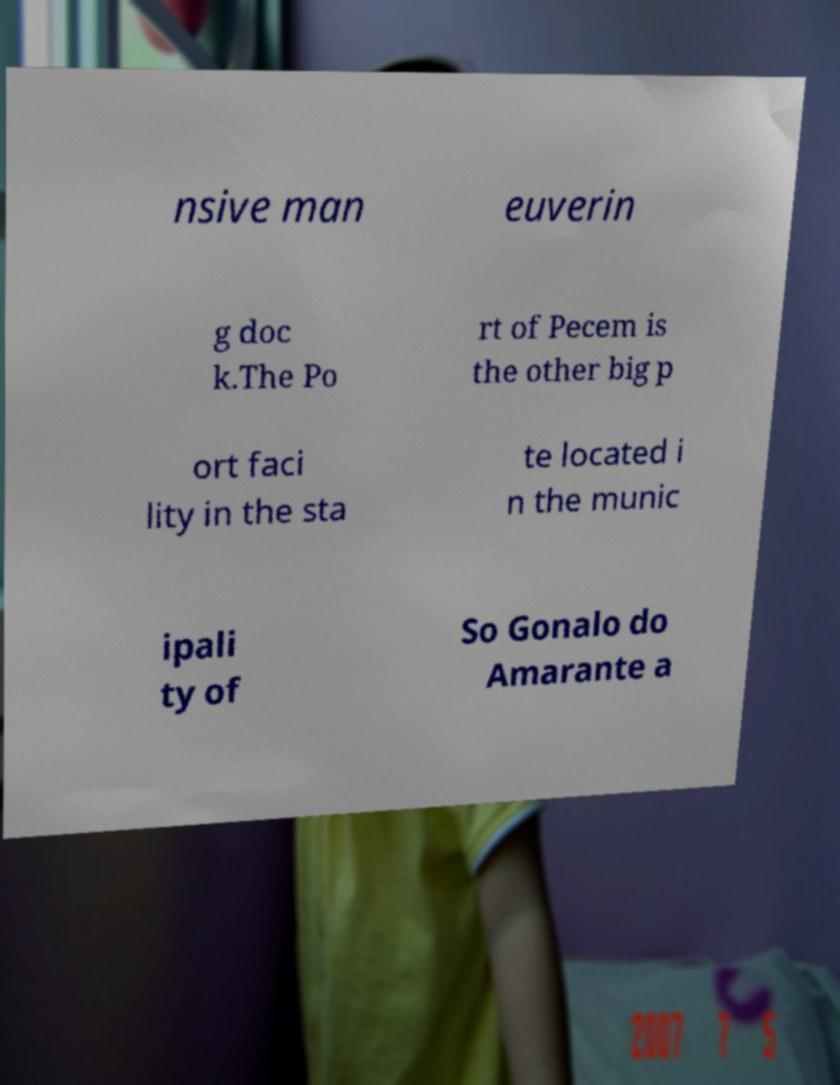Please read and relay the text visible in this image. What does it say? nsive man euverin g doc k.The Po rt of Pecem is the other big p ort faci lity in the sta te located i n the munic ipali ty of So Gonalo do Amarante a 